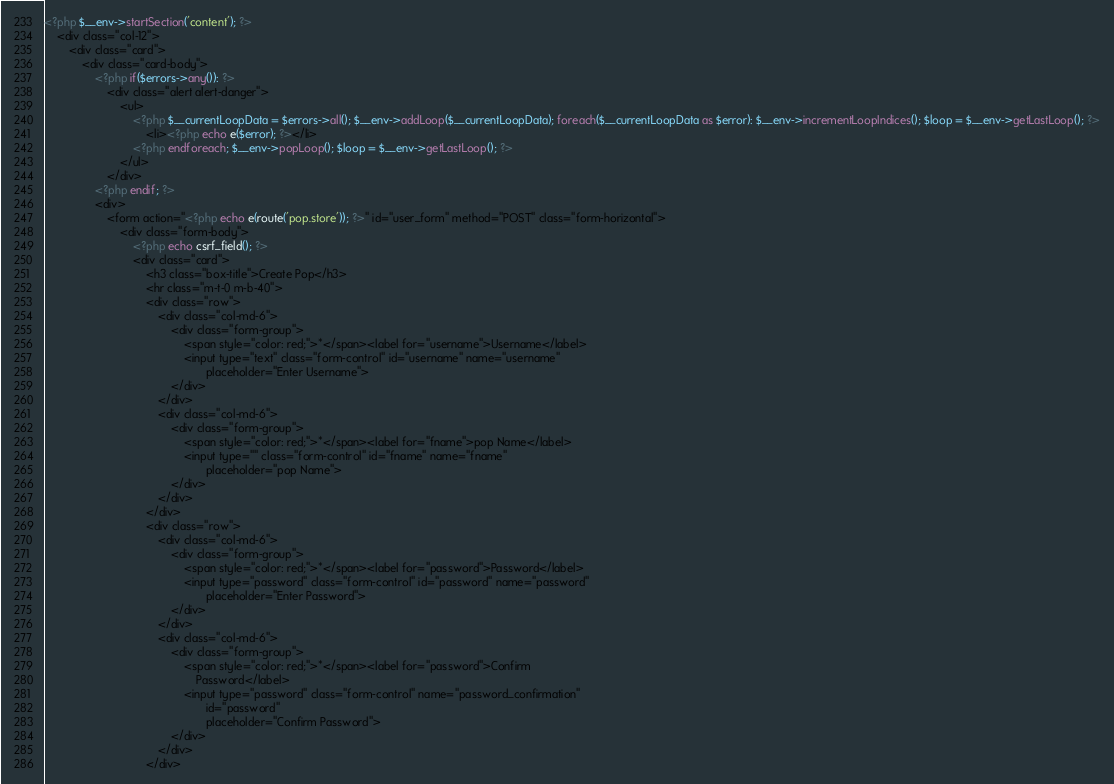<code> <loc_0><loc_0><loc_500><loc_500><_PHP_><?php $__env->startSection('content'); ?>
    <div class="col-12">
        <div class="card">
            <div class="card-body">
                <?php if($errors->any()): ?>
                    <div class="alert alert-danger">
                        <ul>
                            <?php $__currentLoopData = $errors->all(); $__env->addLoop($__currentLoopData); foreach($__currentLoopData as $error): $__env->incrementLoopIndices(); $loop = $__env->getLastLoop(); ?>
                                <li><?php echo e($error); ?></li>
                            <?php endforeach; $__env->popLoop(); $loop = $__env->getLastLoop(); ?>
                        </ul>
                    </div>
                <?php endif; ?>
                <div>
                    <form action="<?php echo e(route('pop.store')); ?>" id="user_form" method="POST" class="form-horizontal">
                        <div class="form-body">
                            <?php echo csrf_field(); ?>
                            <div class="card">
                                <h3 class="box-title">Create Pop</h3>
                                <hr class="m-t-0 m-b-40">
                                <div class="row">
                                    <div class="col-md-6">
                                        <div class="form-group">
                                            <span style="color: red;">*</span><label for="username">Username</label>
                                            <input type="text" class="form-control" id="username" name="username"
                                                   placeholder="Enter Username">
                                        </div>
                                    </div>
                                    <div class="col-md-6">
                                        <div class="form-group">
                                            <span style="color: red;">*</span><label for="fname">pop Name</label>
                                            <input type="" class="form-control" id="fname" name="fname"
                                                   placeholder="pop Name">
                                        </div>
                                    </div>
                                </div>
                                <div class="row">
                                    <div class="col-md-6">
                                        <div class="form-group">
                                            <span style="color: red;">*</span><label for="password">Password</label>
                                            <input type="password" class="form-control" id="password" name="password"
                                                   placeholder="Enter Password">
                                        </div>
                                    </div>
                                    <div class="col-md-6">
                                        <div class="form-group">
                                            <span style="color: red;">*</span><label for="password">Confirm
                                                Password</label>
                                            <input type="password" class="form-control" name="password_confirmation"
                                                   id="password"
                                                   placeholder="Confirm Password">
                                        </div>
                                    </div>
                                </div></code> 